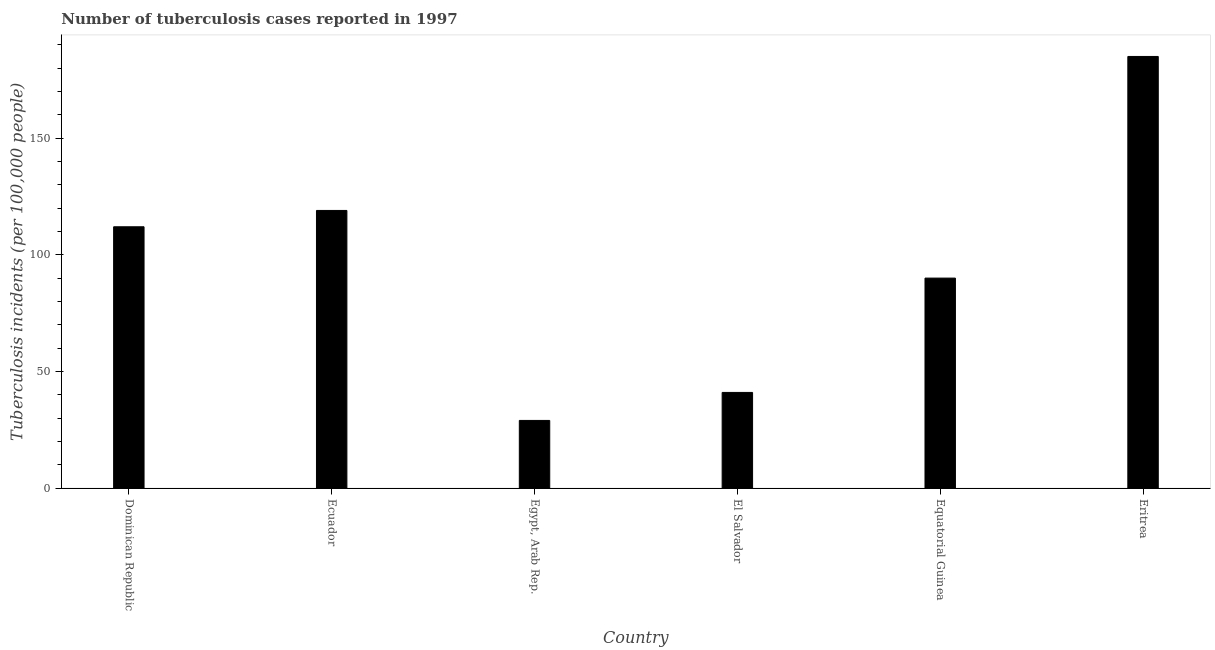Does the graph contain grids?
Provide a short and direct response. No. What is the title of the graph?
Your response must be concise. Number of tuberculosis cases reported in 1997. What is the label or title of the Y-axis?
Ensure brevity in your answer.  Tuberculosis incidents (per 100,0 people). Across all countries, what is the maximum number of tuberculosis incidents?
Ensure brevity in your answer.  185. Across all countries, what is the minimum number of tuberculosis incidents?
Provide a short and direct response. 29. In which country was the number of tuberculosis incidents maximum?
Your response must be concise. Eritrea. In which country was the number of tuberculosis incidents minimum?
Your response must be concise. Egypt, Arab Rep. What is the sum of the number of tuberculosis incidents?
Ensure brevity in your answer.  576. What is the difference between the number of tuberculosis incidents in Dominican Republic and Ecuador?
Your response must be concise. -7. What is the average number of tuberculosis incidents per country?
Your answer should be compact. 96. What is the median number of tuberculosis incidents?
Offer a very short reply. 101. In how many countries, is the number of tuberculosis incidents greater than 70 ?
Give a very brief answer. 4. What is the ratio of the number of tuberculosis incidents in Dominican Republic to that in Equatorial Guinea?
Ensure brevity in your answer.  1.24. Is the number of tuberculosis incidents in Ecuador less than that in Egypt, Arab Rep.?
Keep it short and to the point. No. Is the difference between the number of tuberculosis incidents in Ecuador and Egypt, Arab Rep. greater than the difference between any two countries?
Your answer should be compact. No. What is the difference between the highest and the second highest number of tuberculosis incidents?
Provide a short and direct response. 66. Is the sum of the number of tuberculosis incidents in Egypt, Arab Rep. and Equatorial Guinea greater than the maximum number of tuberculosis incidents across all countries?
Give a very brief answer. No. What is the difference between the highest and the lowest number of tuberculosis incidents?
Provide a short and direct response. 156. Are all the bars in the graph horizontal?
Provide a short and direct response. No. Are the values on the major ticks of Y-axis written in scientific E-notation?
Your response must be concise. No. What is the Tuberculosis incidents (per 100,000 people) in Dominican Republic?
Offer a very short reply. 112. What is the Tuberculosis incidents (per 100,000 people) of Ecuador?
Give a very brief answer. 119. What is the Tuberculosis incidents (per 100,000 people) in El Salvador?
Ensure brevity in your answer.  41. What is the Tuberculosis incidents (per 100,000 people) of Equatorial Guinea?
Provide a short and direct response. 90. What is the Tuberculosis incidents (per 100,000 people) in Eritrea?
Offer a terse response. 185. What is the difference between the Tuberculosis incidents (per 100,000 people) in Dominican Republic and El Salvador?
Provide a short and direct response. 71. What is the difference between the Tuberculosis incidents (per 100,000 people) in Dominican Republic and Equatorial Guinea?
Make the answer very short. 22. What is the difference between the Tuberculosis incidents (per 100,000 people) in Dominican Republic and Eritrea?
Provide a short and direct response. -73. What is the difference between the Tuberculosis incidents (per 100,000 people) in Ecuador and El Salvador?
Offer a very short reply. 78. What is the difference between the Tuberculosis incidents (per 100,000 people) in Ecuador and Equatorial Guinea?
Provide a succinct answer. 29. What is the difference between the Tuberculosis incidents (per 100,000 people) in Ecuador and Eritrea?
Your response must be concise. -66. What is the difference between the Tuberculosis incidents (per 100,000 people) in Egypt, Arab Rep. and El Salvador?
Give a very brief answer. -12. What is the difference between the Tuberculosis incidents (per 100,000 people) in Egypt, Arab Rep. and Equatorial Guinea?
Provide a succinct answer. -61. What is the difference between the Tuberculosis incidents (per 100,000 people) in Egypt, Arab Rep. and Eritrea?
Your answer should be compact. -156. What is the difference between the Tuberculosis incidents (per 100,000 people) in El Salvador and Equatorial Guinea?
Offer a terse response. -49. What is the difference between the Tuberculosis incidents (per 100,000 people) in El Salvador and Eritrea?
Offer a very short reply. -144. What is the difference between the Tuberculosis incidents (per 100,000 people) in Equatorial Guinea and Eritrea?
Ensure brevity in your answer.  -95. What is the ratio of the Tuberculosis incidents (per 100,000 people) in Dominican Republic to that in Ecuador?
Offer a terse response. 0.94. What is the ratio of the Tuberculosis incidents (per 100,000 people) in Dominican Republic to that in Egypt, Arab Rep.?
Make the answer very short. 3.86. What is the ratio of the Tuberculosis incidents (per 100,000 people) in Dominican Republic to that in El Salvador?
Provide a succinct answer. 2.73. What is the ratio of the Tuberculosis incidents (per 100,000 people) in Dominican Republic to that in Equatorial Guinea?
Offer a very short reply. 1.24. What is the ratio of the Tuberculosis incidents (per 100,000 people) in Dominican Republic to that in Eritrea?
Your response must be concise. 0.6. What is the ratio of the Tuberculosis incidents (per 100,000 people) in Ecuador to that in Egypt, Arab Rep.?
Provide a short and direct response. 4.1. What is the ratio of the Tuberculosis incidents (per 100,000 people) in Ecuador to that in El Salvador?
Provide a short and direct response. 2.9. What is the ratio of the Tuberculosis incidents (per 100,000 people) in Ecuador to that in Equatorial Guinea?
Offer a very short reply. 1.32. What is the ratio of the Tuberculosis incidents (per 100,000 people) in Ecuador to that in Eritrea?
Your answer should be compact. 0.64. What is the ratio of the Tuberculosis incidents (per 100,000 people) in Egypt, Arab Rep. to that in El Salvador?
Make the answer very short. 0.71. What is the ratio of the Tuberculosis incidents (per 100,000 people) in Egypt, Arab Rep. to that in Equatorial Guinea?
Your response must be concise. 0.32. What is the ratio of the Tuberculosis incidents (per 100,000 people) in Egypt, Arab Rep. to that in Eritrea?
Your response must be concise. 0.16. What is the ratio of the Tuberculosis incidents (per 100,000 people) in El Salvador to that in Equatorial Guinea?
Your answer should be very brief. 0.46. What is the ratio of the Tuberculosis incidents (per 100,000 people) in El Salvador to that in Eritrea?
Your answer should be very brief. 0.22. What is the ratio of the Tuberculosis incidents (per 100,000 people) in Equatorial Guinea to that in Eritrea?
Give a very brief answer. 0.49. 